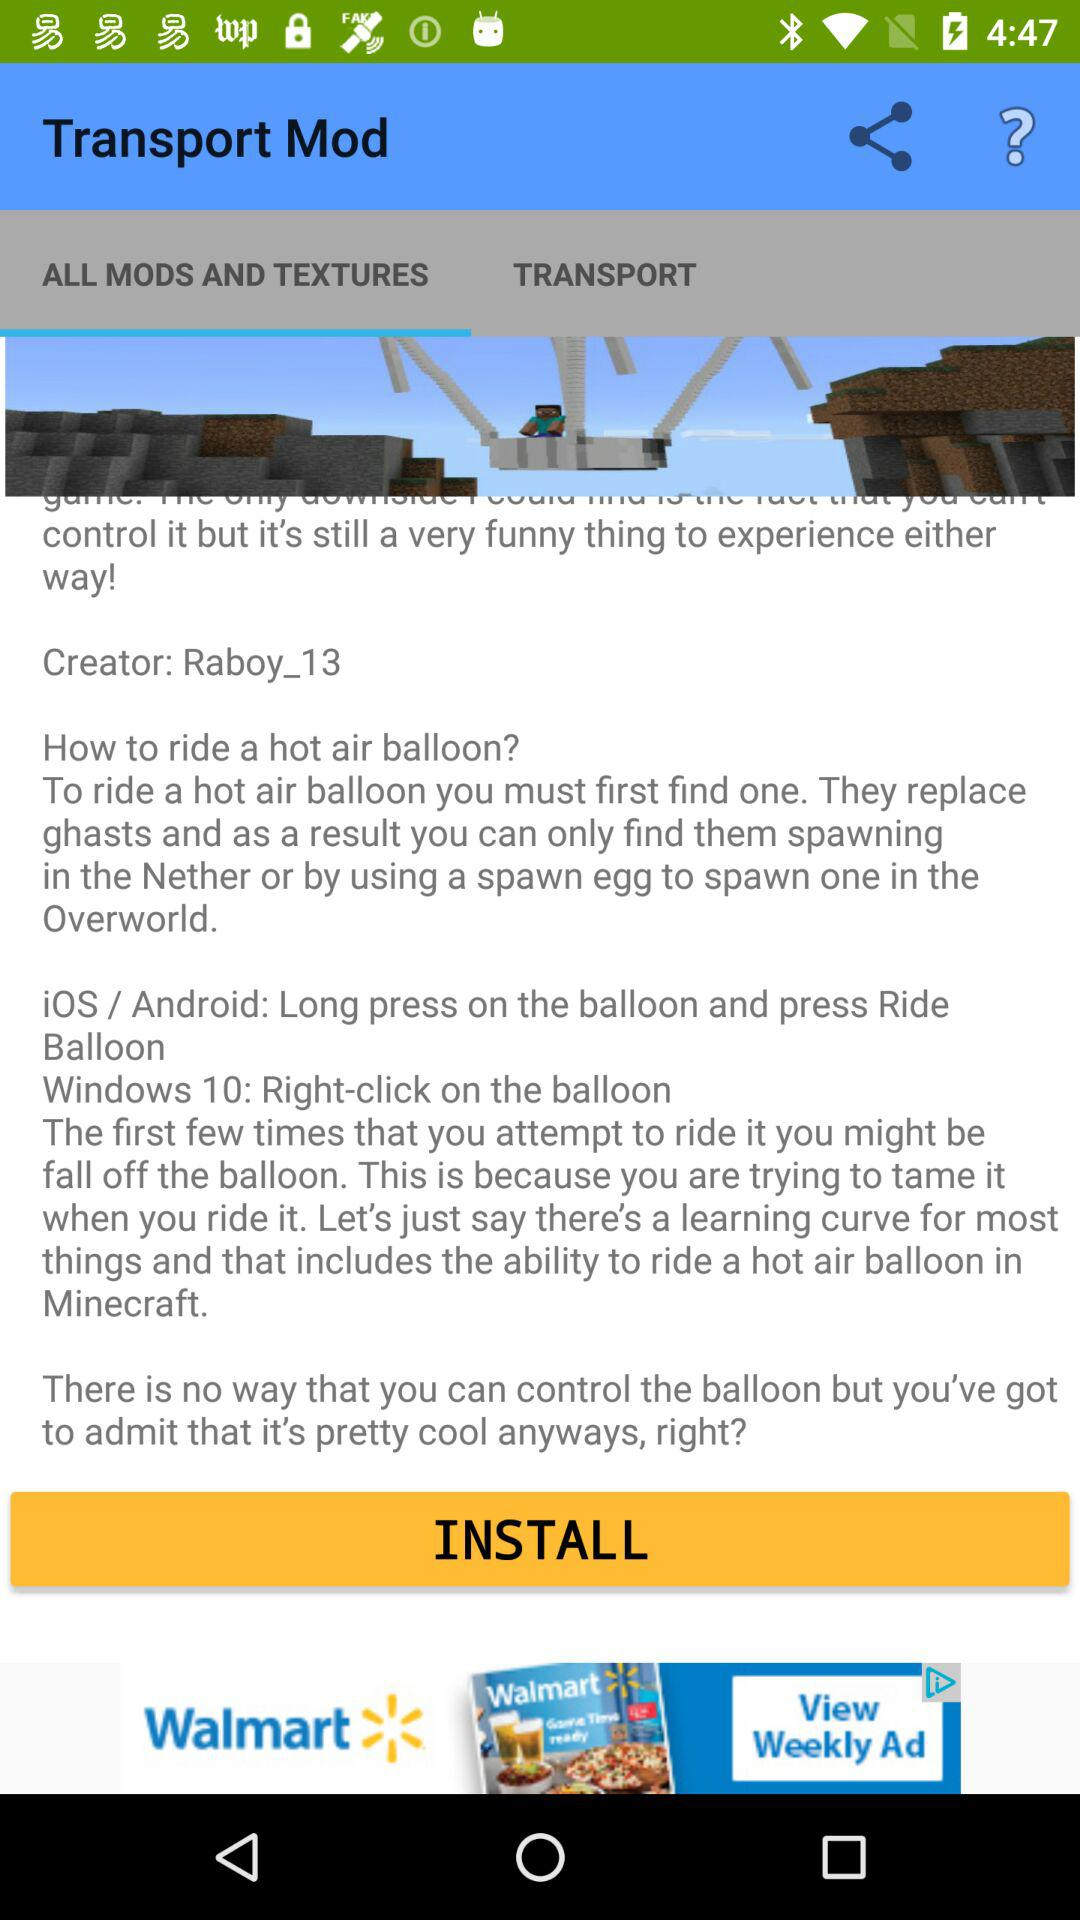What's the creator name? The creator name is "Raboy_13". 